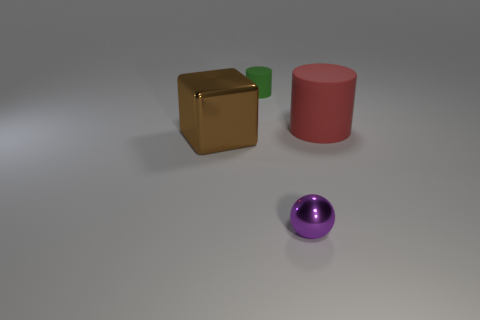Is there any other thing that is the same size as the metallic cube?
Offer a very short reply. Yes. Are there fewer tiny objects on the left side of the tiny cylinder than small matte things?
Make the answer very short. Yes. Do the purple shiny thing and the large matte object have the same shape?
Your answer should be compact. No. The big thing that is the same shape as the tiny green rubber thing is what color?
Your answer should be very brief. Red. How many rubber cylinders have the same color as the cube?
Offer a terse response. 0. What number of things are either tiny things that are behind the big brown cube or green cylinders?
Give a very brief answer. 1. There is a metal thing that is right of the large brown block; what size is it?
Give a very brief answer. Small. Is the number of purple metallic balls less than the number of small cyan metallic spheres?
Offer a very short reply. No. Does the cylinder behind the red cylinder have the same material as the cylinder to the right of the green object?
Keep it short and to the point. Yes. The matte object behind the matte cylinder that is in front of the matte cylinder behind the big red thing is what shape?
Give a very brief answer. Cylinder. 